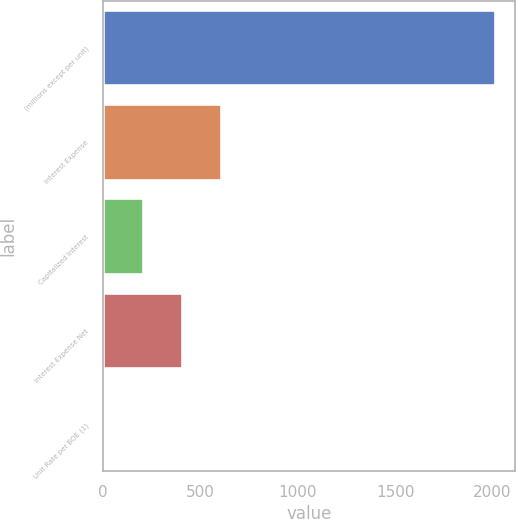<chart> <loc_0><loc_0><loc_500><loc_500><bar_chart><fcel>(millions except per unit)<fcel>Interest Expense<fcel>Capitalized Interest<fcel>Interest Expense Net<fcel>Unit Rate per BOE (1)<nl><fcel>2014<fcel>605.57<fcel>203.17<fcel>404.37<fcel>1.97<nl></chart> 